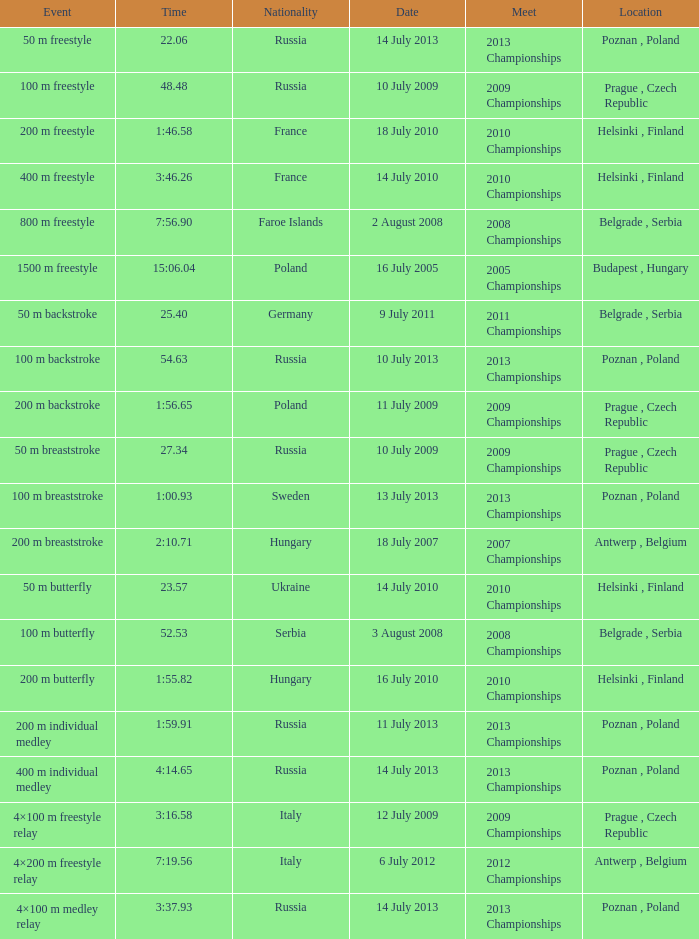What date was the 1500 m freestyle competition? 16 July 2005. 